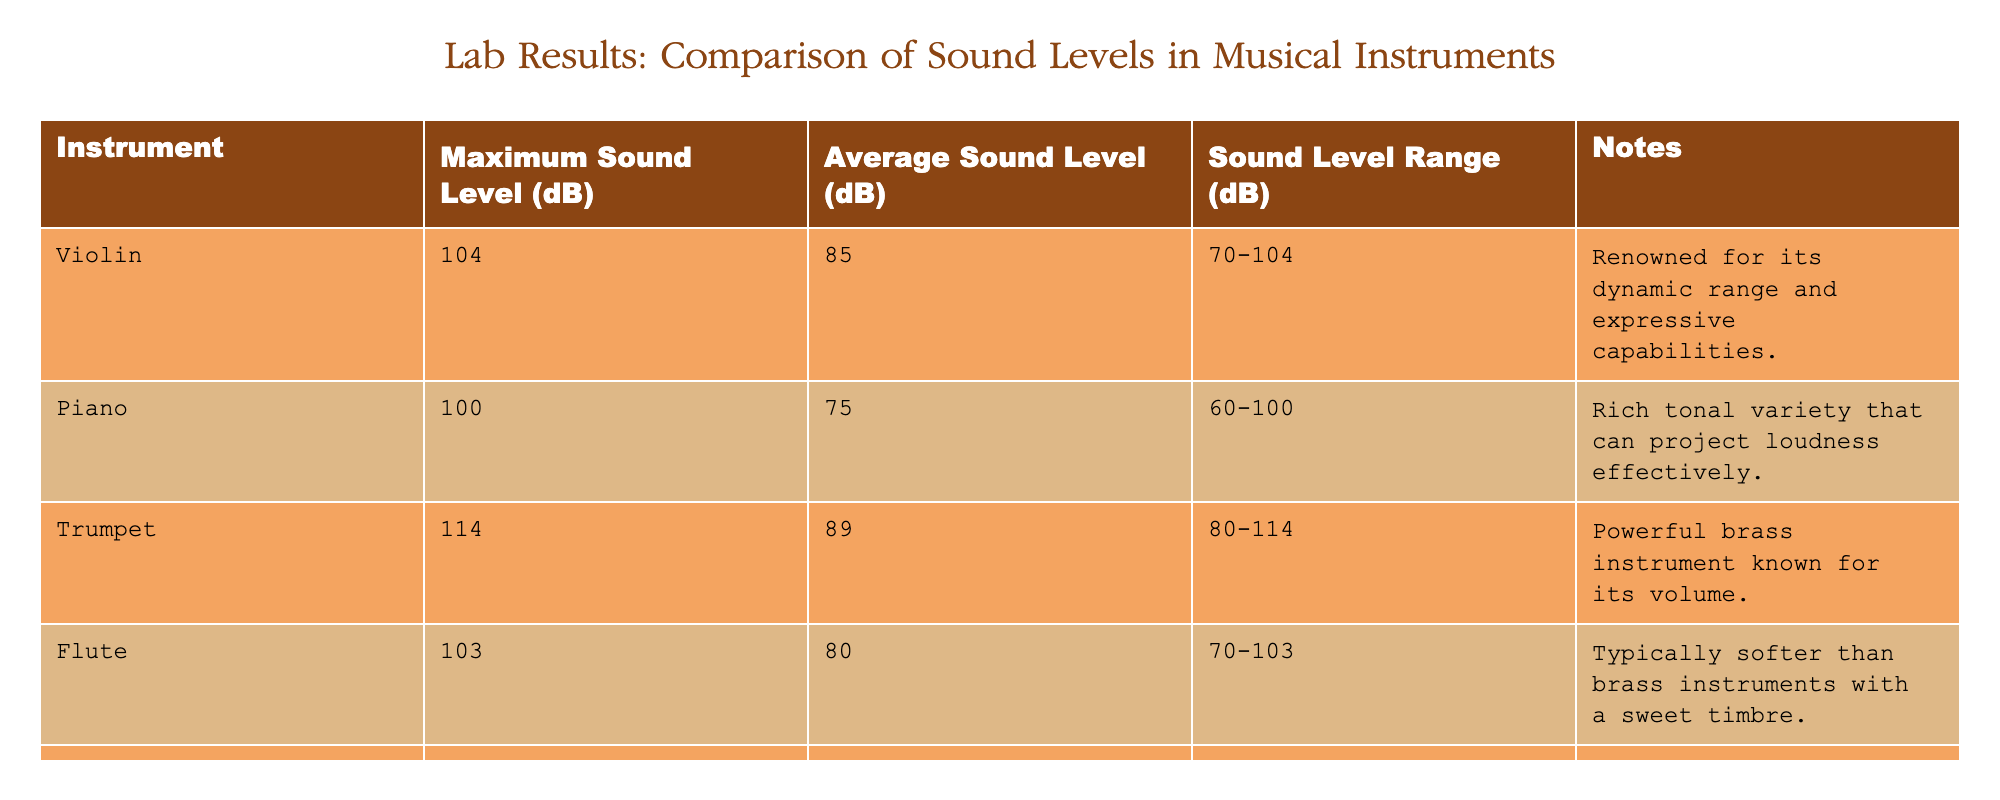What is the maximum sound level recorded for the trumpet? The trumpet's maximum sound level is listed in the table under the "Maximum Sound Level (dB)" column. Looking specifically at the trumpet row, it shows a value of 114 dB.
Answer: 114 dB What is the average sound level of the guitar? The average sound level for the guitar can be found in the "Average Sound Level (dB)" column. For the guitar, this value is 76 dB, as seen in the table.
Answer: 76 dB Is the average sound level of the flute higher than that of the piano? The average sound levels for both instruments are 80 dB for the flute and 75 dB for the piano. Since 80 is greater than 75, the average sound level of the flute is indeed higher.
Answer: Yes Which instrument has the widest sound level range? To determine the widest range, we need to subtract the minimum sound level from the maximum sound level for each instrument. For the violin, the range is 34 dB (104 - 70). For the piano, it's 40 dB (100 - 60). For the trumpet, it's 34 dB (114 - 80). For the flute, it's 33 dB (103 - 70). For the guitar, it's 35 dB (95 - 60). For the saxophone, it's 44 dB (116 - 72). Comparing these ranges, the saxophone has the widest range of 44 dB.
Answer: Saxophone What is the total of the maximum sound levels for all instruments listed? To find the total maximum sound levels, we need to sum the maximum levels of each instrument from the table. They are: 104 (violin) + 100 (piano) + 114 (trumpet) + 103 (flute) + 95 (guitar) + 116 (saxophone) = 732 dB. Therefore, the total is 732 dB.
Answer: 732 dB 